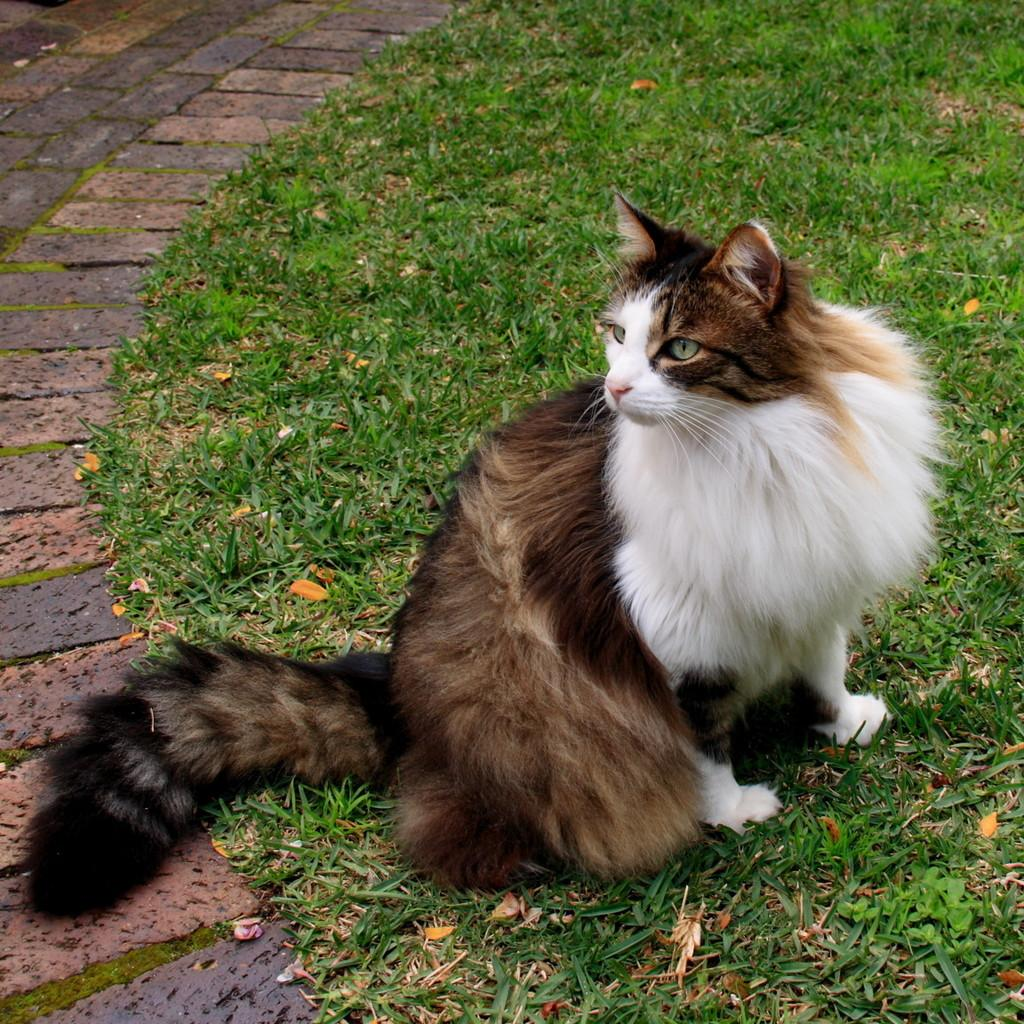What animal can be seen in the image? There is a cat in the image. Where is the cat located? The cat is sitting on the grass. grass. What is visible on the left side of the image? There is a path on the left side of the image. How many cakes are being carried by the sheep in the image? There are no sheep or cakes present in the image. 